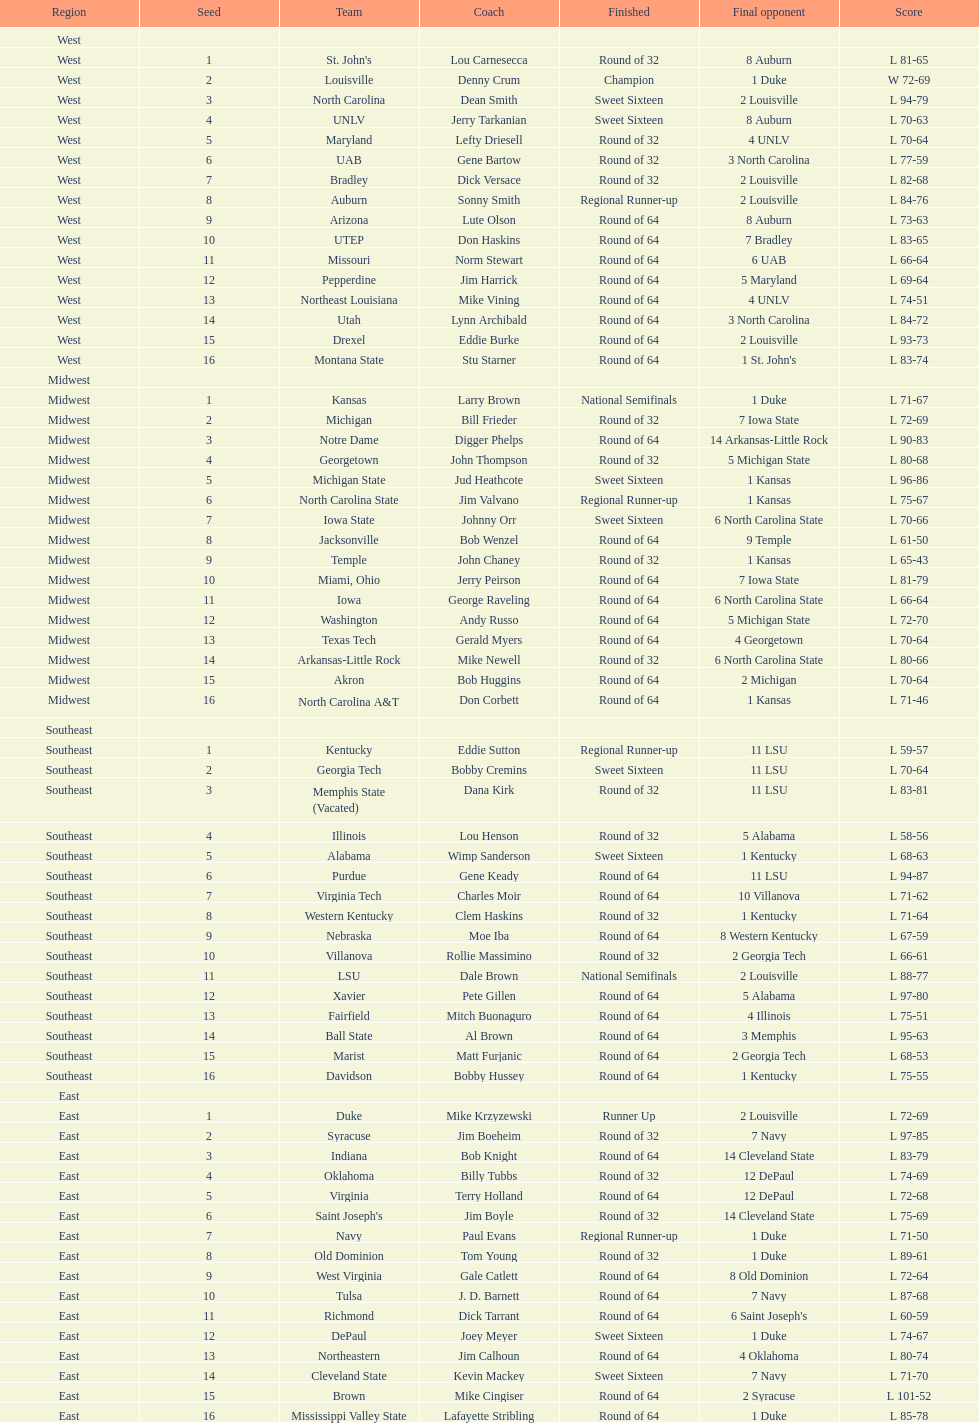Who is the only team from the east region to reach the final round? Duke. 